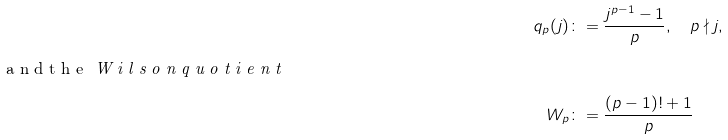<formula> <loc_0><loc_0><loc_500><loc_500>q _ { p } ( j ) & \colon = \frac { j ^ { p - 1 } - 1 } { p } , \quad p \nmid j , \intertext { a n d t h e \emph { W i l s o n q u o t i e n t } } W _ { p } & \colon = \frac { ( p - 1 ) ! + 1 } { p }</formula> 